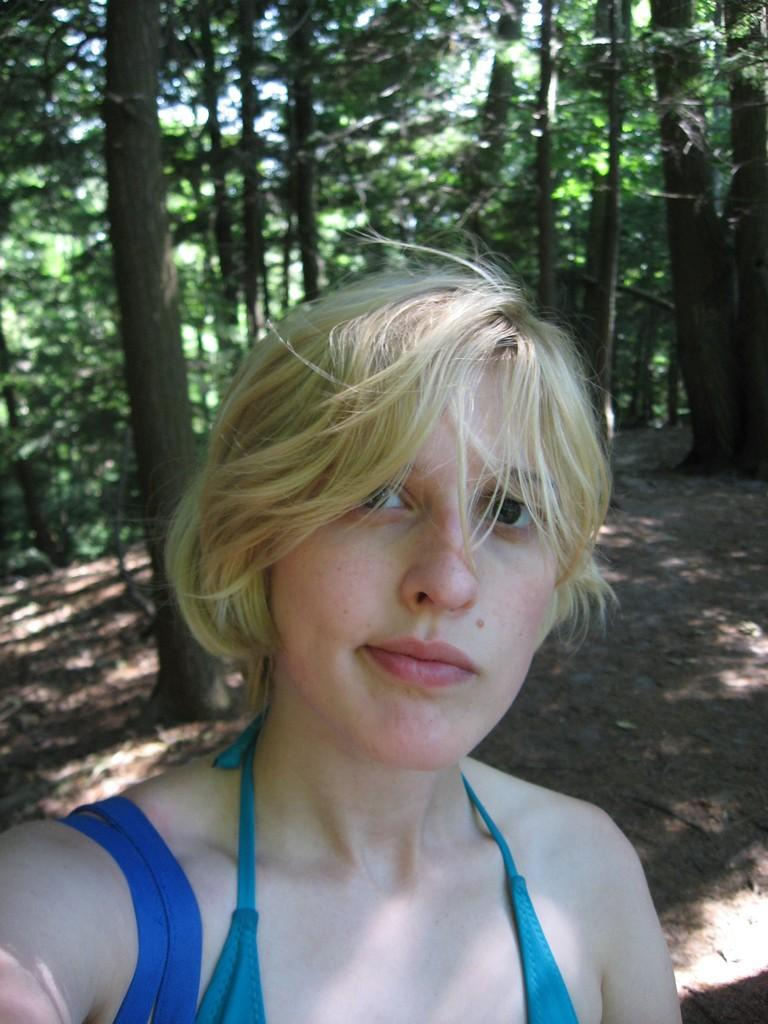What is present in the image? There is a person in the image. What can be seen in the background of the image? There are green trees in the background of the image. What type of wire is being used by the person in the image? There is no wire visible in the image. What kind of insect can be seen crawling on the person's suit in the image? There is no insect or suit present in the image. 